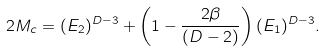Convert formula to latex. <formula><loc_0><loc_0><loc_500><loc_500>2 M _ { c } = ( E _ { 2 } ) ^ { D - 3 } + \left ( 1 - \frac { 2 \beta } { ( D - 2 ) } \right ) ( E _ { 1 } ) ^ { D - 3 } .</formula> 